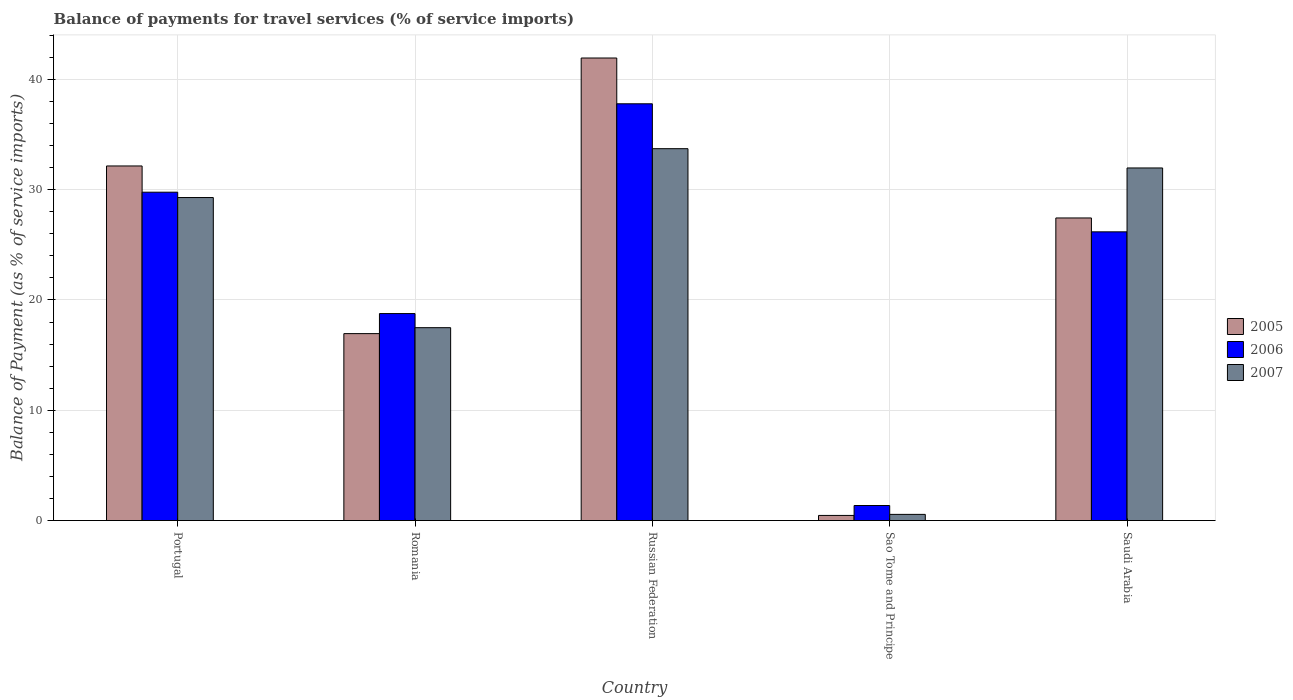How many different coloured bars are there?
Give a very brief answer. 3. How many groups of bars are there?
Provide a short and direct response. 5. Are the number of bars on each tick of the X-axis equal?
Ensure brevity in your answer.  Yes. How many bars are there on the 1st tick from the right?
Provide a short and direct response. 3. What is the label of the 5th group of bars from the left?
Provide a short and direct response. Saudi Arabia. What is the balance of payments for travel services in 2005 in Portugal?
Your response must be concise. 32.15. Across all countries, what is the maximum balance of payments for travel services in 2007?
Your answer should be compact. 33.72. Across all countries, what is the minimum balance of payments for travel services in 2007?
Provide a succinct answer. 0.56. In which country was the balance of payments for travel services in 2007 maximum?
Provide a succinct answer. Russian Federation. In which country was the balance of payments for travel services in 2007 minimum?
Your answer should be very brief. Sao Tome and Principe. What is the total balance of payments for travel services in 2007 in the graph?
Make the answer very short. 113.02. What is the difference between the balance of payments for travel services in 2007 in Russian Federation and that in Saudi Arabia?
Your answer should be compact. 1.75. What is the difference between the balance of payments for travel services in 2005 in Saudi Arabia and the balance of payments for travel services in 2006 in Russian Federation?
Offer a very short reply. -10.35. What is the average balance of payments for travel services in 2007 per country?
Offer a very short reply. 22.6. What is the difference between the balance of payments for travel services of/in 2005 and balance of payments for travel services of/in 2007 in Saudi Arabia?
Provide a succinct answer. -4.53. In how many countries, is the balance of payments for travel services in 2005 greater than 30 %?
Provide a short and direct response. 2. What is the ratio of the balance of payments for travel services in 2005 in Russian Federation to that in Sao Tome and Principe?
Your answer should be very brief. 89.84. Is the difference between the balance of payments for travel services in 2005 in Romania and Sao Tome and Principe greater than the difference between the balance of payments for travel services in 2007 in Romania and Sao Tome and Principe?
Keep it short and to the point. No. What is the difference between the highest and the second highest balance of payments for travel services in 2005?
Keep it short and to the point. -9.79. What is the difference between the highest and the lowest balance of payments for travel services in 2005?
Offer a very short reply. 41.47. What does the 1st bar from the right in Russian Federation represents?
Your answer should be very brief. 2007. How many countries are there in the graph?
Ensure brevity in your answer.  5. What is the difference between two consecutive major ticks on the Y-axis?
Your answer should be very brief. 10. Are the values on the major ticks of Y-axis written in scientific E-notation?
Provide a short and direct response. No. Does the graph contain any zero values?
Ensure brevity in your answer.  No. Does the graph contain grids?
Keep it short and to the point. Yes. Where does the legend appear in the graph?
Keep it short and to the point. Center right. What is the title of the graph?
Ensure brevity in your answer.  Balance of payments for travel services (% of service imports). Does "1964" appear as one of the legend labels in the graph?
Your response must be concise. No. What is the label or title of the X-axis?
Give a very brief answer. Country. What is the label or title of the Y-axis?
Offer a terse response. Balance of Payment (as % of service imports). What is the Balance of Payment (as % of service imports) of 2005 in Portugal?
Provide a succinct answer. 32.15. What is the Balance of Payment (as % of service imports) of 2006 in Portugal?
Your answer should be very brief. 29.77. What is the Balance of Payment (as % of service imports) of 2007 in Portugal?
Offer a terse response. 29.29. What is the Balance of Payment (as % of service imports) of 2005 in Romania?
Ensure brevity in your answer.  16.95. What is the Balance of Payment (as % of service imports) in 2006 in Romania?
Your response must be concise. 18.77. What is the Balance of Payment (as % of service imports) in 2007 in Romania?
Your answer should be compact. 17.49. What is the Balance of Payment (as % of service imports) of 2005 in Russian Federation?
Make the answer very short. 41.94. What is the Balance of Payment (as % of service imports) in 2006 in Russian Federation?
Offer a very short reply. 37.78. What is the Balance of Payment (as % of service imports) in 2007 in Russian Federation?
Your answer should be compact. 33.72. What is the Balance of Payment (as % of service imports) of 2005 in Sao Tome and Principe?
Offer a terse response. 0.47. What is the Balance of Payment (as % of service imports) in 2006 in Sao Tome and Principe?
Offer a terse response. 1.37. What is the Balance of Payment (as % of service imports) in 2007 in Sao Tome and Principe?
Provide a succinct answer. 0.56. What is the Balance of Payment (as % of service imports) in 2005 in Saudi Arabia?
Give a very brief answer. 27.44. What is the Balance of Payment (as % of service imports) in 2006 in Saudi Arabia?
Provide a short and direct response. 26.18. What is the Balance of Payment (as % of service imports) in 2007 in Saudi Arabia?
Ensure brevity in your answer.  31.97. Across all countries, what is the maximum Balance of Payment (as % of service imports) of 2005?
Ensure brevity in your answer.  41.94. Across all countries, what is the maximum Balance of Payment (as % of service imports) in 2006?
Keep it short and to the point. 37.78. Across all countries, what is the maximum Balance of Payment (as % of service imports) of 2007?
Your answer should be compact. 33.72. Across all countries, what is the minimum Balance of Payment (as % of service imports) of 2005?
Provide a succinct answer. 0.47. Across all countries, what is the minimum Balance of Payment (as % of service imports) in 2006?
Provide a succinct answer. 1.37. Across all countries, what is the minimum Balance of Payment (as % of service imports) of 2007?
Provide a short and direct response. 0.56. What is the total Balance of Payment (as % of service imports) in 2005 in the graph?
Give a very brief answer. 118.94. What is the total Balance of Payment (as % of service imports) in 2006 in the graph?
Make the answer very short. 113.86. What is the total Balance of Payment (as % of service imports) in 2007 in the graph?
Your response must be concise. 113.02. What is the difference between the Balance of Payment (as % of service imports) of 2005 in Portugal and that in Romania?
Keep it short and to the point. 15.2. What is the difference between the Balance of Payment (as % of service imports) of 2006 in Portugal and that in Romania?
Provide a short and direct response. 11. What is the difference between the Balance of Payment (as % of service imports) of 2007 in Portugal and that in Romania?
Provide a short and direct response. 11.8. What is the difference between the Balance of Payment (as % of service imports) in 2005 in Portugal and that in Russian Federation?
Make the answer very short. -9.79. What is the difference between the Balance of Payment (as % of service imports) of 2006 in Portugal and that in Russian Federation?
Make the answer very short. -8.01. What is the difference between the Balance of Payment (as % of service imports) in 2007 in Portugal and that in Russian Federation?
Your response must be concise. -4.43. What is the difference between the Balance of Payment (as % of service imports) in 2005 in Portugal and that in Sao Tome and Principe?
Offer a terse response. 31.68. What is the difference between the Balance of Payment (as % of service imports) of 2006 in Portugal and that in Sao Tome and Principe?
Your answer should be very brief. 28.4. What is the difference between the Balance of Payment (as % of service imports) of 2007 in Portugal and that in Sao Tome and Principe?
Your answer should be very brief. 28.72. What is the difference between the Balance of Payment (as % of service imports) in 2005 in Portugal and that in Saudi Arabia?
Provide a short and direct response. 4.71. What is the difference between the Balance of Payment (as % of service imports) in 2006 in Portugal and that in Saudi Arabia?
Provide a short and direct response. 3.59. What is the difference between the Balance of Payment (as % of service imports) in 2007 in Portugal and that in Saudi Arabia?
Keep it short and to the point. -2.68. What is the difference between the Balance of Payment (as % of service imports) in 2005 in Romania and that in Russian Federation?
Provide a short and direct response. -24.99. What is the difference between the Balance of Payment (as % of service imports) of 2006 in Romania and that in Russian Federation?
Provide a short and direct response. -19.02. What is the difference between the Balance of Payment (as % of service imports) in 2007 in Romania and that in Russian Federation?
Ensure brevity in your answer.  -16.23. What is the difference between the Balance of Payment (as % of service imports) in 2005 in Romania and that in Sao Tome and Principe?
Keep it short and to the point. 16.48. What is the difference between the Balance of Payment (as % of service imports) in 2006 in Romania and that in Sao Tome and Principe?
Your response must be concise. 17.4. What is the difference between the Balance of Payment (as % of service imports) of 2007 in Romania and that in Sao Tome and Principe?
Your response must be concise. 16.93. What is the difference between the Balance of Payment (as % of service imports) of 2005 in Romania and that in Saudi Arabia?
Your answer should be very brief. -10.49. What is the difference between the Balance of Payment (as % of service imports) in 2006 in Romania and that in Saudi Arabia?
Your answer should be very brief. -7.41. What is the difference between the Balance of Payment (as % of service imports) in 2007 in Romania and that in Saudi Arabia?
Provide a short and direct response. -14.48. What is the difference between the Balance of Payment (as % of service imports) of 2005 in Russian Federation and that in Sao Tome and Principe?
Offer a terse response. 41.47. What is the difference between the Balance of Payment (as % of service imports) in 2006 in Russian Federation and that in Sao Tome and Principe?
Provide a succinct answer. 36.42. What is the difference between the Balance of Payment (as % of service imports) in 2007 in Russian Federation and that in Sao Tome and Principe?
Your answer should be very brief. 33.15. What is the difference between the Balance of Payment (as % of service imports) in 2005 in Russian Federation and that in Saudi Arabia?
Make the answer very short. 14.5. What is the difference between the Balance of Payment (as % of service imports) of 2006 in Russian Federation and that in Saudi Arabia?
Your answer should be very brief. 11.61. What is the difference between the Balance of Payment (as % of service imports) in 2007 in Russian Federation and that in Saudi Arabia?
Keep it short and to the point. 1.75. What is the difference between the Balance of Payment (as % of service imports) of 2005 in Sao Tome and Principe and that in Saudi Arabia?
Keep it short and to the point. -26.97. What is the difference between the Balance of Payment (as % of service imports) in 2006 in Sao Tome and Principe and that in Saudi Arabia?
Your answer should be compact. -24.81. What is the difference between the Balance of Payment (as % of service imports) in 2007 in Sao Tome and Principe and that in Saudi Arabia?
Your answer should be compact. -31.41. What is the difference between the Balance of Payment (as % of service imports) in 2005 in Portugal and the Balance of Payment (as % of service imports) in 2006 in Romania?
Keep it short and to the point. 13.38. What is the difference between the Balance of Payment (as % of service imports) in 2005 in Portugal and the Balance of Payment (as % of service imports) in 2007 in Romania?
Make the answer very short. 14.66. What is the difference between the Balance of Payment (as % of service imports) in 2006 in Portugal and the Balance of Payment (as % of service imports) in 2007 in Romania?
Your response must be concise. 12.28. What is the difference between the Balance of Payment (as % of service imports) of 2005 in Portugal and the Balance of Payment (as % of service imports) of 2006 in Russian Federation?
Give a very brief answer. -5.64. What is the difference between the Balance of Payment (as % of service imports) of 2005 in Portugal and the Balance of Payment (as % of service imports) of 2007 in Russian Federation?
Make the answer very short. -1.57. What is the difference between the Balance of Payment (as % of service imports) in 2006 in Portugal and the Balance of Payment (as % of service imports) in 2007 in Russian Federation?
Provide a succinct answer. -3.95. What is the difference between the Balance of Payment (as % of service imports) of 2005 in Portugal and the Balance of Payment (as % of service imports) of 2006 in Sao Tome and Principe?
Offer a terse response. 30.78. What is the difference between the Balance of Payment (as % of service imports) of 2005 in Portugal and the Balance of Payment (as % of service imports) of 2007 in Sao Tome and Principe?
Provide a short and direct response. 31.59. What is the difference between the Balance of Payment (as % of service imports) of 2006 in Portugal and the Balance of Payment (as % of service imports) of 2007 in Sao Tome and Principe?
Provide a short and direct response. 29.21. What is the difference between the Balance of Payment (as % of service imports) of 2005 in Portugal and the Balance of Payment (as % of service imports) of 2006 in Saudi Arabia?
Keep it short and to the point. 5.97. What is the difference between the Balance of Payment (as % of service imports) of 2005 in Portugal and the Balance of Payment (as % of service imports) of 2007 in Saudi Arabia?
Offer a terse response. 0.18. What is the difference between the Balance of Payment (as % of service imports) in 2006 in Portugal and the Balance of Payment (as % of service imports) in 2007 in Saudi Arabia?
Offer a very short reply. -2.2. What is the difference between the Balance of Payment (as % of service imports) of 2005 in Romania and the Balance of Payment (as % of service imports) of 2006 in Russian Federation?
Keep it short and to the point. -20.84. What is the difference between the Balance of Payment (as % of service imports) of 2005 in Romania and the Balance of Payment (as % of service imports) of 2007 in Russian Federation?
Provide a short and direct response. -16.77. What is the difference between the Balance of Payment (as % of service imports) of 2006 in Romania and the Balance of Payment (as % of service imports) of 2007 in Russian Federation?
Your answer should be compact. -14.95. What is the difference between the Balance of Payment (as % of service imports) in 2005 in Romania and the Balance of Payment (as % of service imports) in 2006 in Sao Tome and Principe?
Provide a succinct answer. 15.58. What is the difference between the Balance of Payment (as % of service imports) in 2005 in Romania and the Balance of Payment (as % of service imports) in 2007 in Sao Tome and Principe?
Ensure brevity in your answer.  16.39. What is the difference between the Balance of Payment (as % of service imports) of 2006 in Romania and the Balance of Payment (as % of service imports) of 2007 in Sao Tome and Principe?
Offer a very short reply. 18.21. What is the difference between the Balance of Payment (as % of service imports) in 2005 in Romania and the Balance of Payment (as % of service imports) in 2006 in Saudi Arabia?
Offer a terse response. -9.23. What is the difference between the Balance of Payment (as % of service imports) of 2005 in Romania and the Balance of Payment (as % of service imports) of 2007 in Saudi Arabia?
Make the answer very short. -15.02. What is the difference between the Balance of Payment (as % of service imports) in 2006 in Romania and the Balance of Payment (as % of service imports) in 2007 in Saudi Arabia?
Keep it short and to the point. -13.2. What is the difference between the Balance of Payment (as % of service imports) in 2005 in Russian Federation and the Balance of Payment (as % of service imports) in 2006 in Sao Tome and Principe?
Offer a terse response. 40.57. What is the difference between the Balance of Payment (as % of service imports) in 2005 in Russian Federation and the Balance of Payment (as % of service imports) in 2007 in Sao Tome and Principe?
Provide a short and direct response. 41.38. What is the difference between the Balance of Payment (as % of service imports) in 2006 in Russian Federation and the Balance of Payment (as % of service imports) in 2007 in Sao Tome and Principe?
Offer a very short reply. 37.22. What is the difference between the Balance of Payment (as % of service imports) in 2005 in Russian Federation and the Balance of Payment (as % of service imports) in 2006 in Saudi Arabia?
Your response must be concise. 15.76. What is the difference between the Balance of Payment (as % of service imports) of 2005 in Russian Federation and the Balance of Payment (as % of service imports) of 2007 in Saudi Arabia?
Offer a very short reply. 9.97. What is the difference between the Balance of Payment (as % of service imports) in 2006 in Russian Federation and the Balance of Payment (as % of service imports) in 2007 in Saudi Arabia?
Ensure brevity in your answer.  5.82. What is the difference between the Balance of Payment (as % of service imports) of 2005 in Sao Tome and Principe and the Balance of Payment (as % of service imports) of 2006 in Saudi Arabia?
Give a very brief answer. -25.71. What is the difference between the Balance of Payment (as % of service imports) in 2005 in Sao Tome and Principe and the Balance of Payment (as % of service imports) in 2007 in Saudi Arabia?
Offer a very short reply. -31.5. What is the difference between the Balance of Payment (as % of service imports) in 2006 in Sao Tome and Principe and the Balance of Payment (as % of service imports) in 2007 in Saudi Arabia?
Provide a succinct answer. -30.6. What is the average Balance of Payment (as % of service imports) of 2005 per country?
Give a very brief answer. 23.79. What is the average Balance of Payment (as % of service imports) of 2006 per country?
Your response must be concise. 22.77. What is the average Balance of Payment (as % of service imports) of 2007 per country?
Provide a succinct answer. 22.6. What is the difference between the Balance of Payment (as % of service imports) of 2005 and Balance of Payment (as % of service imports) of 2006 in Portugal?
Offer a terse response. 2.38. What is the difference between the Balance of Payment (as % of service imports) of 2005 and Balance of Payment (as % of service imports) of 2007 in Portugal?
Give a very brief answer. 2.86. What is the difference between the Balance of Payment (as % of service imports) of 2006 and Balance of Payment (as % of service imports) of 2007 in Portugal?
Provide a succinct answer. 0.48. What is the difference between the Balance of Payment (as % of service imports) in 2005 and Balance of Payment (as % of service imports) in 2006 in Romania?
Ensure brevity in your answer.  -1.82. What is the difference between the Balance of Payment (as % of service imports) of 2005 and Balance of Payment (as % of service imports) of 2007 in Romania?
Provide a short and direct response. -0.54. What is the difference between the Balance of Payment (as % of service imports) of 2006 and Balance of Payment (as % of service imports) of 2007 in Romania?
Give a very brief answer. 1.28. What is the difference between the Balance of Payment (as % of service imports) of 2005 and Balance of Payment (as % of service imports) of 2006 in Russian Federation?
Keep it short and to the point. 4.15. What is the difference between the Balance of Payment (as % of service imports) in 2005 and Balance of Payment (as % of service imports) in 2007 in Russian Federation?
Keep it short and to the point. 8.22. What is the difference between the Balance of Payment (as % of service imports) in 2006 and Balance of Payment (as % of service imports) in 2007 in Russian Federation?
Make the answer very short. 4.07. What is the difference between the Balance of Payment (as % of service imports) of 2005 and Balance of Payment (as % of service imports) of 2006 in Sao Tome and Principe?
Provide a succinct answer. -0.9. What is the difference between the Balance of Payment (as % of service imports) in 2005 and Balance of Payment (as % of service imports) in 2007 in Sao Tome and Principe?
Offer a very short reply. -0.09. What is the difference between the Balance of Payment (as % of service imports) of 2006 and Balance of Payment (as % of service imports) of 2007 in Sao Tome and Principe?
Offer a terse response. 0.8. What is the difference between the Balance of Payment (as % of service imports) in 2005 and Balance of Payment (as % of service imports) in 2006 in Saudi Arabia?
Your answer should be very brief. 1.26. What is the difference between the Balance of Payment (as % of service imports) in 2005 and Balance of Payment (as % of service imports) in 2007 in Saudi Arabia?
Your response must be concise. -4.53. What is the difference between the Balance of Payment (as % of service imports) of 2006 and Balance of Payment (as % of service imports) of 2007 in Saudi Arabia?
Give a very brief answer. -5.79. What is the ratio of the Balance of Payment (as % of service imports) of 2005 in Portugal to that in Romania?
Ensure brevity in your answer.  1.9. What is the ratio of the Balance of Payment (as % of service imports) of 2006 in Portugal to that in Romania?
Your response must be concise. 1.59. What is the ratio of the Balance of Payment (as % of service imports) in 2007 in Portugal to that in Romania?
Your answer should be very brief. 1.67. What is the ratio of the Balance of Payment (as % of service imports) of 2005 in Portugal to that in Russian Federation?
Offer a very short reply. 0.77. What is the ratio of the Balance of Payment (as % of service imports) of 2006 in Portugal to that in Russian Federation?
Offer a terse response. 0.79. What is the ratio of the Balance of Payment (as % of service imports) of 2007 in Portugal to that in Russian Federation?
Your answer should be very brief. 0.87. What is the ratio of the Balance of Payment (as % of service imports) in 2005 in Portugal to that in Sao Tome and Principe?
Ensure brevity in your answer.  68.87. What is the ratio of the Balance of Payment (as % of service imports) in 2006 in Portugal to that in Sao Tome and Principe?
Ensure brevity in your answer.  21.8. What is the ratio of the Balance of Payment (as % of service imports) of 2007 in Portugal to that in Sao Tome and Principe?
Your response must be concise. 52.17. What is the ratio of the Balance of Payment (as % of service imports) of 2005 in Portugal to that in Saudi Arabia?
Your answer should be compact. 1.17. What is the ratio of the Balance of Payment (as % of service imports) in 2006 in Portugal to that in Saudi Arabia?
Ensure brevity in your answer.  1.14. What is the ratio of the Balance of Payment (as % of service imports) in 2007 in Portugal to that in Saudi Arabia?
Your response must be concise. 0.92. What is the ratio of the Balance of Payment (as % of service imports) in 2005 in Romania to that in Russian Federation?
Keep it short and to the point. 0.4. What is the ratio of the Balance of Payment (as % of service imports) in 2006 in Romania to that in Russian Federation?
Your answer should be compact. 0.5. What is the ratio of the Balance of Payment (as % of service imports) in 2007 in Romania to that in Russian Federation?
Ensure brevity in your answer.  0.52. What is the ratio of the Balance of Payment (as % of service imports) of 2005 in Romania to that in Sao Tome and Principe?
Ensure brevity in your answer.  36.31. What is the ratio of the Balance of Payment (as % of service imports) in 2006 in Romania to that in Sao Tome and Principe?
Your answer should be compact. 13.74. What is the ratio of the Balance of Payment (as % of service imports) of 2007 in Romania to that in Sao Tome and Principe?
Your answer should be very brief. 31.15. What is the ratio of the Balance of Payment (as % of service imports) of 2005 in Romania to that in Saudi Arabia?
Keep it short and to the point. 0.62. What is the ratio of the Balance of Payment (as % of service imports) in 2006 in Romania to that in Saudi Arabia?
Offer a very short reply. 0.72. What is the ratio of the Balance of Payment (as % of service imports) of 2007 in Romania to that in Saudi Arabia?
Provide a short and direct response. 0.55. What is the ratio of the Balance of Payment (as % of service imports) of 2005 in Russian Federation to that in Sao Tome and Principe?
Provide a short and direct response. 89.84. What is the ratio of the Balance of Payment (as % of service imports) in 2006 in Russian Federation to that in Sao Tome and Principe?
Your answer should be compact. 27.67. What is the ratio of the Balance of Payment (as % of service imports) of 2007 in Russian Federation to that in Sao Tome and Principe?
Offer a terse response. 60.06. What is the ratio of the Balance of Payment (as % of service imports) in 2005 in Russian Federation to that in Saudi Arabia?
Provide a short and direct response. 1.53. What is the ratio of the Balance of Payment (as % of service imports) in 2006 in Russian Federation to that in Saudi Arabia?
Your answer should be very brief. 1.44. What is the ratio of the Balance of Payment (as % of service imports) of 2007 in Russian Federation to that in Saudi Arabia?
Keep it short and to the point. 1.05. What is the ratio of the Balance of Payment (as % of service imports) of 2005 in Sao Tome and Principe to that in Saudi Arabia?
Give a very brief answer. 0.02. What is the ratio of the Balance of Payment (as % of service imports) in 2006 in Sao Tome and Principe to that in Saudi Arabia?
Make the answer very short. 0.05. What is the ratio of the Balance of Payment (as % of service imports) in 2007 in Sao Tome and Principe to that in Saudi Arabia?
Your response must be concise. 0.02. What is the difference between the highest and the second highest Balance of Payment (as % of service imports) in 2005?
Your response must be concise. 9.79. What is the difference between the highest and the second highest Balance of Payment (as % of service imports) in 2006?
Your answer should be compact. 8.01. What is the difference between the highest and the second highest Balance of Payment (as % of service imports) in 2007?
Offer a very short reply. 1.75. What is the difference between the highest and the lowest Balance of Payment (as % of service imports) in 2005?
Give a very brief answer. 41.47. What is the difference between the highest and the lowest Balance of Payment (as % of service imports) in 2006?
Keep it short and to the point. 36.42. What is the difference between the highest and the lowest Balance of Payment (as % of service imports) of 2007?
Provide a succinct answer. 33.15. 